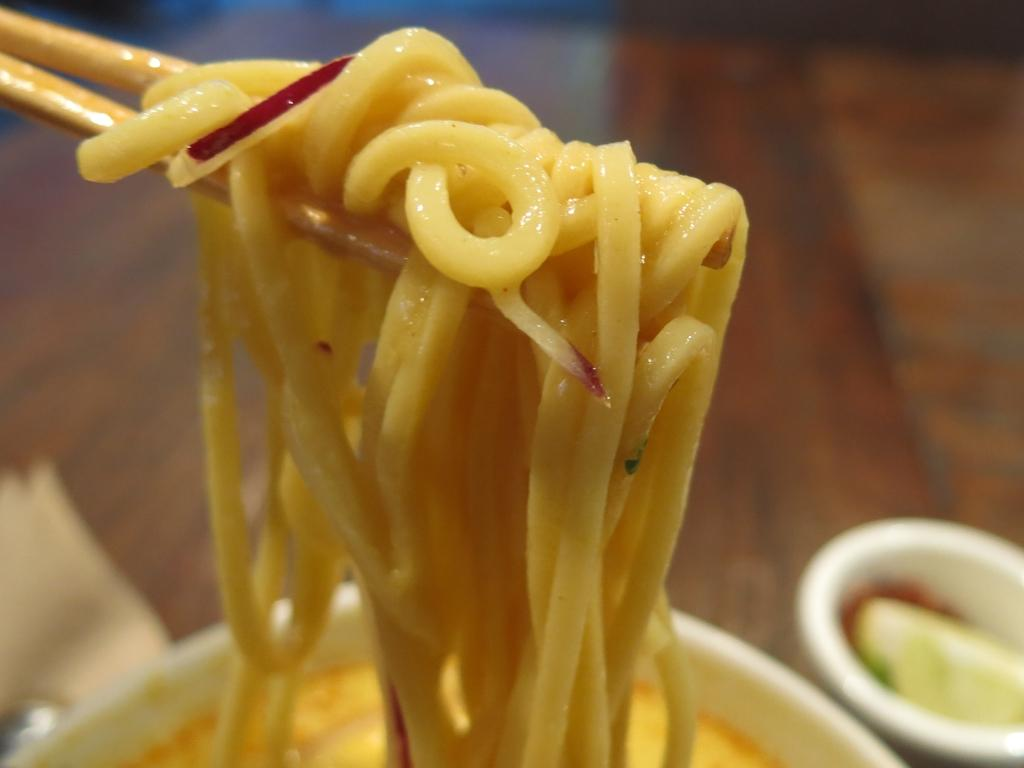What type of food is shown in the image? There are noodles in the image. What are the plates used for in the image? The plates are used to hold the noodles. What utensil is shown with the noodles? Chopsticks are visible in the image. What type of experience does the spy have while stretching in the image? There is no spy or stretching present in the image; it features noodles, plates, and chopsticks. 